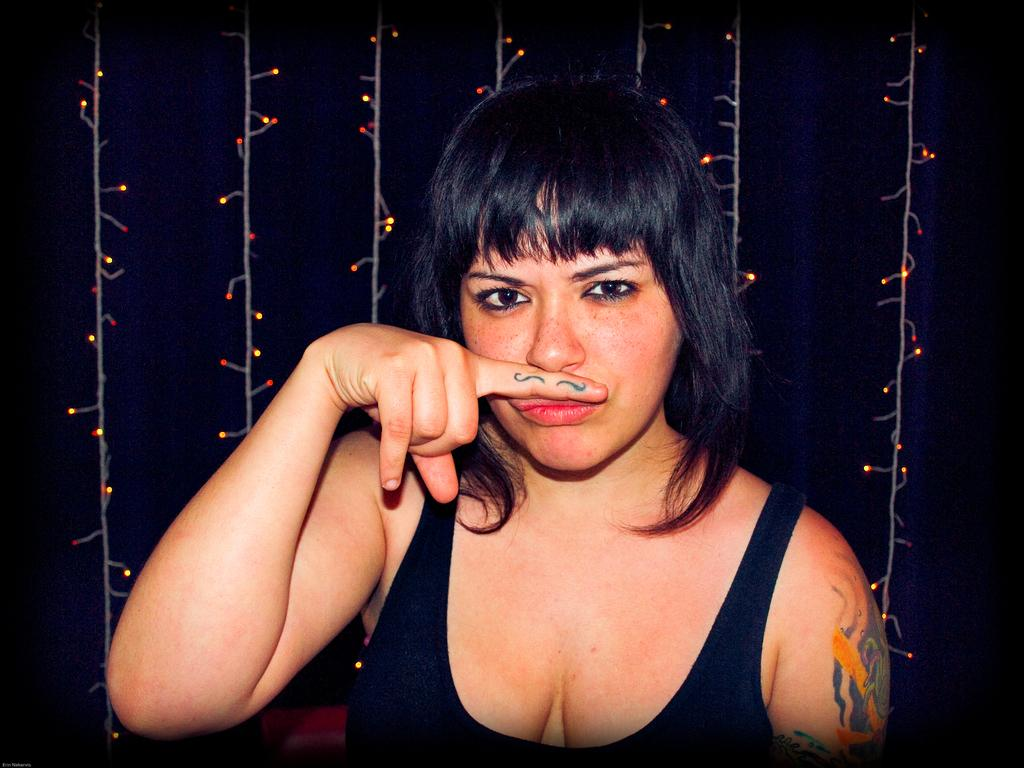Who is the main subject in the image? There is a woman in the image. What is the woman wearing? The woman is wearing a black dress. What is the woman doing in the image? The woman is posing for the picture. What can be seen in the background of the image? There are lights visible in the background, and the background is in black color. Can you see the woman's sister in the image? There is no mention of a sister in the image, so it cannot be determined if she is present. What type of worm is crawling on the woman's dress in the image? There is no worm present in the image; the woman is wearing a black dress. 